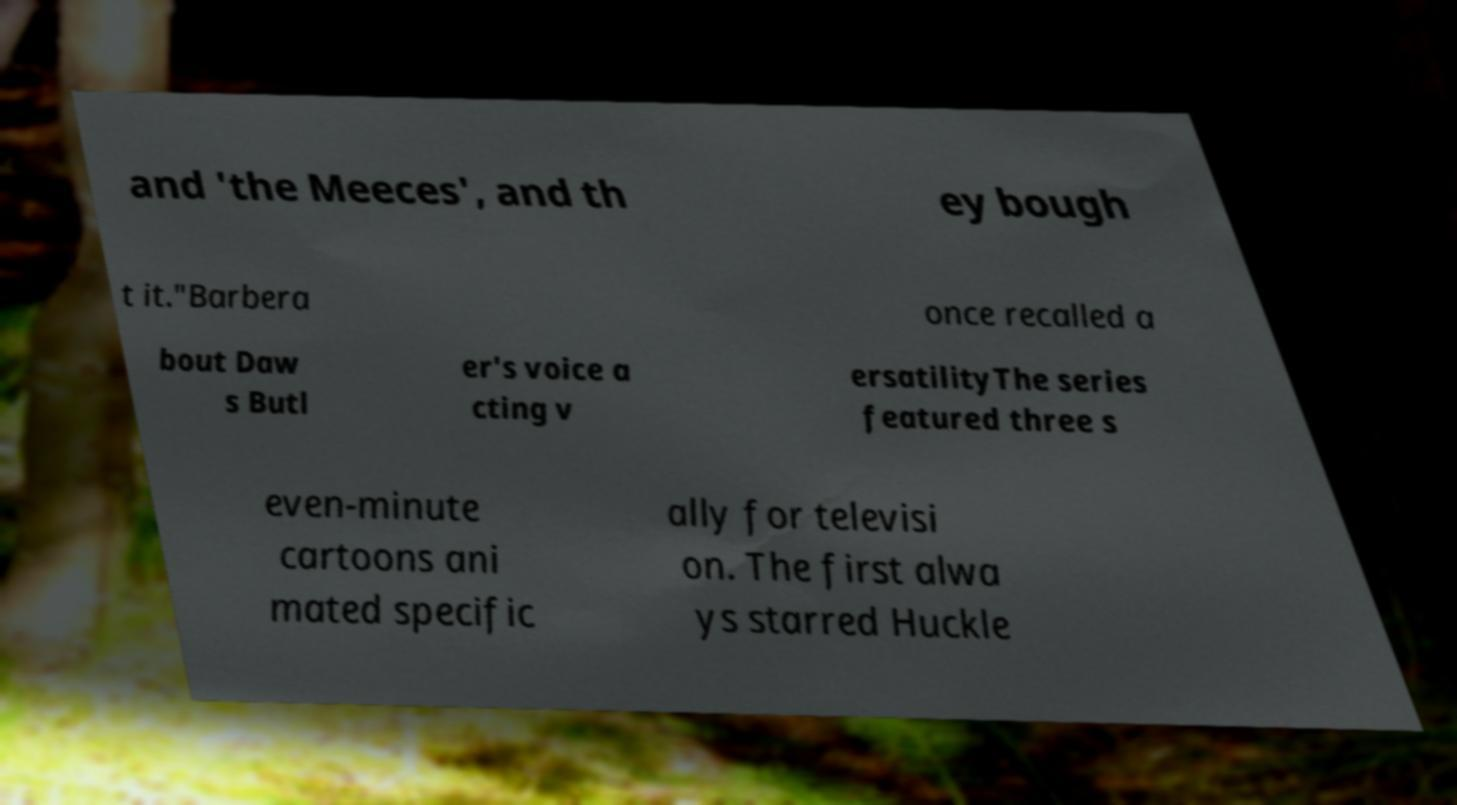Could you assist in decoding the text presented in this image and type it out clearly? and 'the Meeces', and th ey bough t it."Barbera once recalled a bout Daw s Butl er's voice a cting v ersatilityThe series featured three s even-minute cartoons ani mated specific ally for televisi on. The first alwa ys starred Huckle 